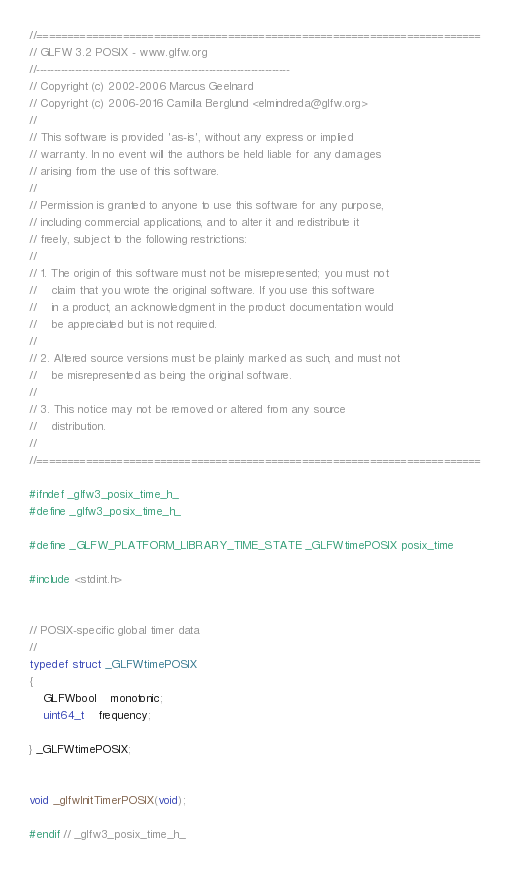Convert code to text. <code><loc_0><loc_0><loc_500><loc_500><_C_>//========================================================================
// GLFW 3.2 POSIX - www.glfw.org
//------------------------------------------------------------------------
// Copyright (c) 2002-2006 Marcus Geelnard
// Copyright (c) 2006-2016 Camilla Berglund <elmindreda@glfw.org>
//
// This software is provided 'as-is', without any express or implied
// warranty. In no event will the authors be held liable for any damages
// arising from the use of this software.
//
// Permission is granted to anyone to use this software for any purpose,
// including commercial applications, and to alter it and redistribute it
// freely, subject to the following restrictions:
//
// 1. The origin of this software must not be misrepresented; you must not
//    claim that you wrote the original software. If you use this software
//    in a product, an acknowledgment in the product documentation would
//    be appreciated but is not required.
//
// 2. Altered source versions must be plainly marked as such, and must not
//    be misrepresented as being the original software.
//
// 3. This notice may not be removed or altered from any source
//    distribution.
//
//========================================================================

#ifndef _glfw3_posix_time_h_
#define _glfw3_posix_time_h_

#define _GLFW_PLATFORM_LIBRARY_TIME_STATE _GLFWtimePOSIX posix_time

#include <stdint.h>


// POSIX-specific global timer data
//
typedef struct _GLFWtimePOSIX
{
    GLFWbool    monotonic;
    uint64_t    frequency;

} _GLFWtimePOSIX;


void _glfwInitTimerPOSIX(void);

#endif // _glfw3_posix_time_h_
</code> 